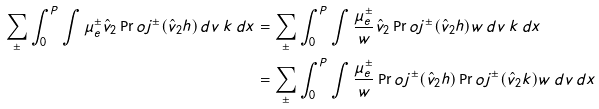Convert formula to latex. <formula><loc_0><loc_0><loc_500><loc_500>\sum _ { \pm } \int _ { 0 } ^ { P } \int \mu ^ { \pm } _ { e } \hat { v } _ { 2 } \Pr o j ^ { \pm } ( \hat { v } _ { 2 } h ) \, d v \, k \, d x & = \sum _ { \pm } \int _ { 0 } ^ { P } \int \frac { \mu ^ { \pm } _ { e } } { w } \hat { v } _ { 2 } \Pr o j ^ { \pm } ( \hat { v } _ { 2 } h ) w \, d v \, k \, d x \\ & = \sum _ { \pm } \int _ { 0 } ^ { P } \int \frac { \mu ^ { \pm } _ { e } } { w } \Pr o j ^ { \pm } ( \hat { v } _ { 2 } h ) \Pr o j ^ { \pm } ( \hat { v } _ { 2 } k ) w \, d v \, d x</formula> 